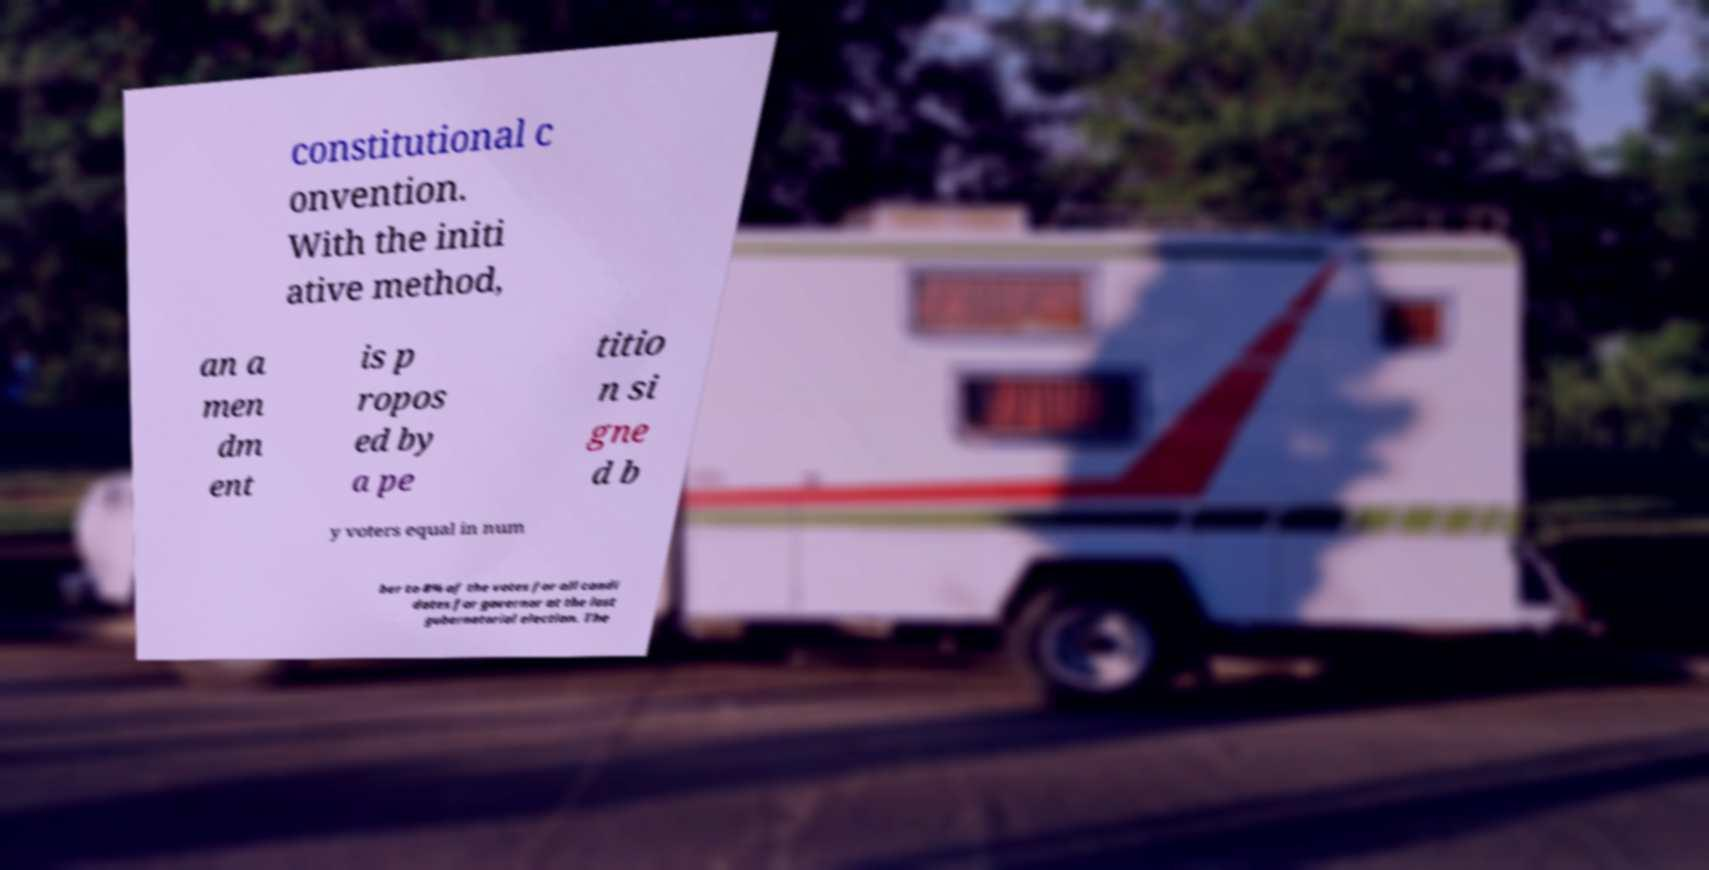Please identify and transcribe the text found in this image. constitutional c onvention. With the initi ative method, an a men dm ent is p ropos ed by a pe titio n si gne d b y voters equal in num ber to 8% of the votes for all candi dates for governor at the last gubernatorial election. The 